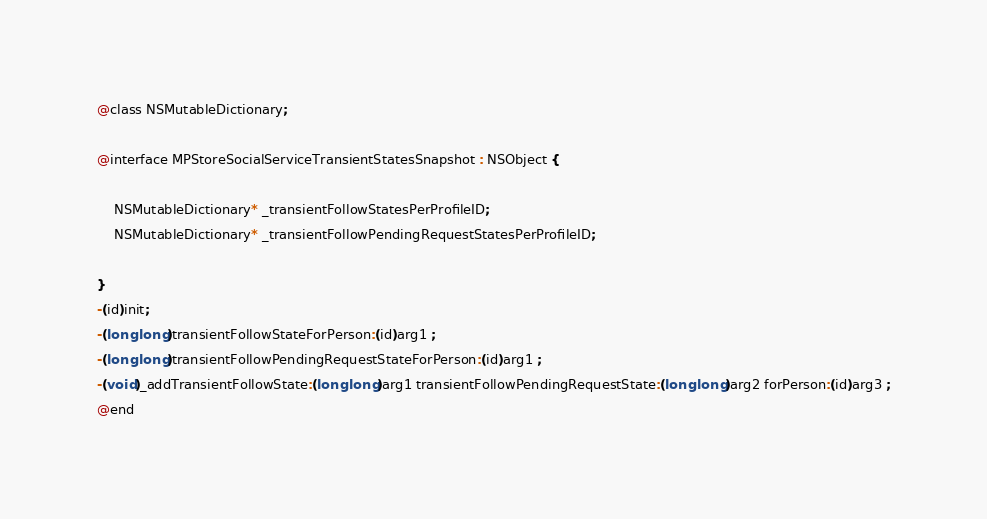<code> <loc_0><loc_0><loc_500><loc_500><_C_>
@class NSMutableDictionary;

@interface MPStoreSocialServiceTransientStatesSnapshot : NSObject {

	NSMutableDictionary* _transientFollowStatesPerProfileID;
	NSMutableDictionary* _transientFollowPendingRequestStatesPerProfileID;

}
-(id)init;
-(long long)transientFollowStateForPerson:(id)arg1 ;
-(long long)transientFollowPendingRequestStateForPerson:(id)arg1 ;
-(void)_addTransientFollowState:(long long)arg1 transientFollowPendingRequestState:(long long)arg2 forPerson:(id)arg3 ;
@end

</code> 